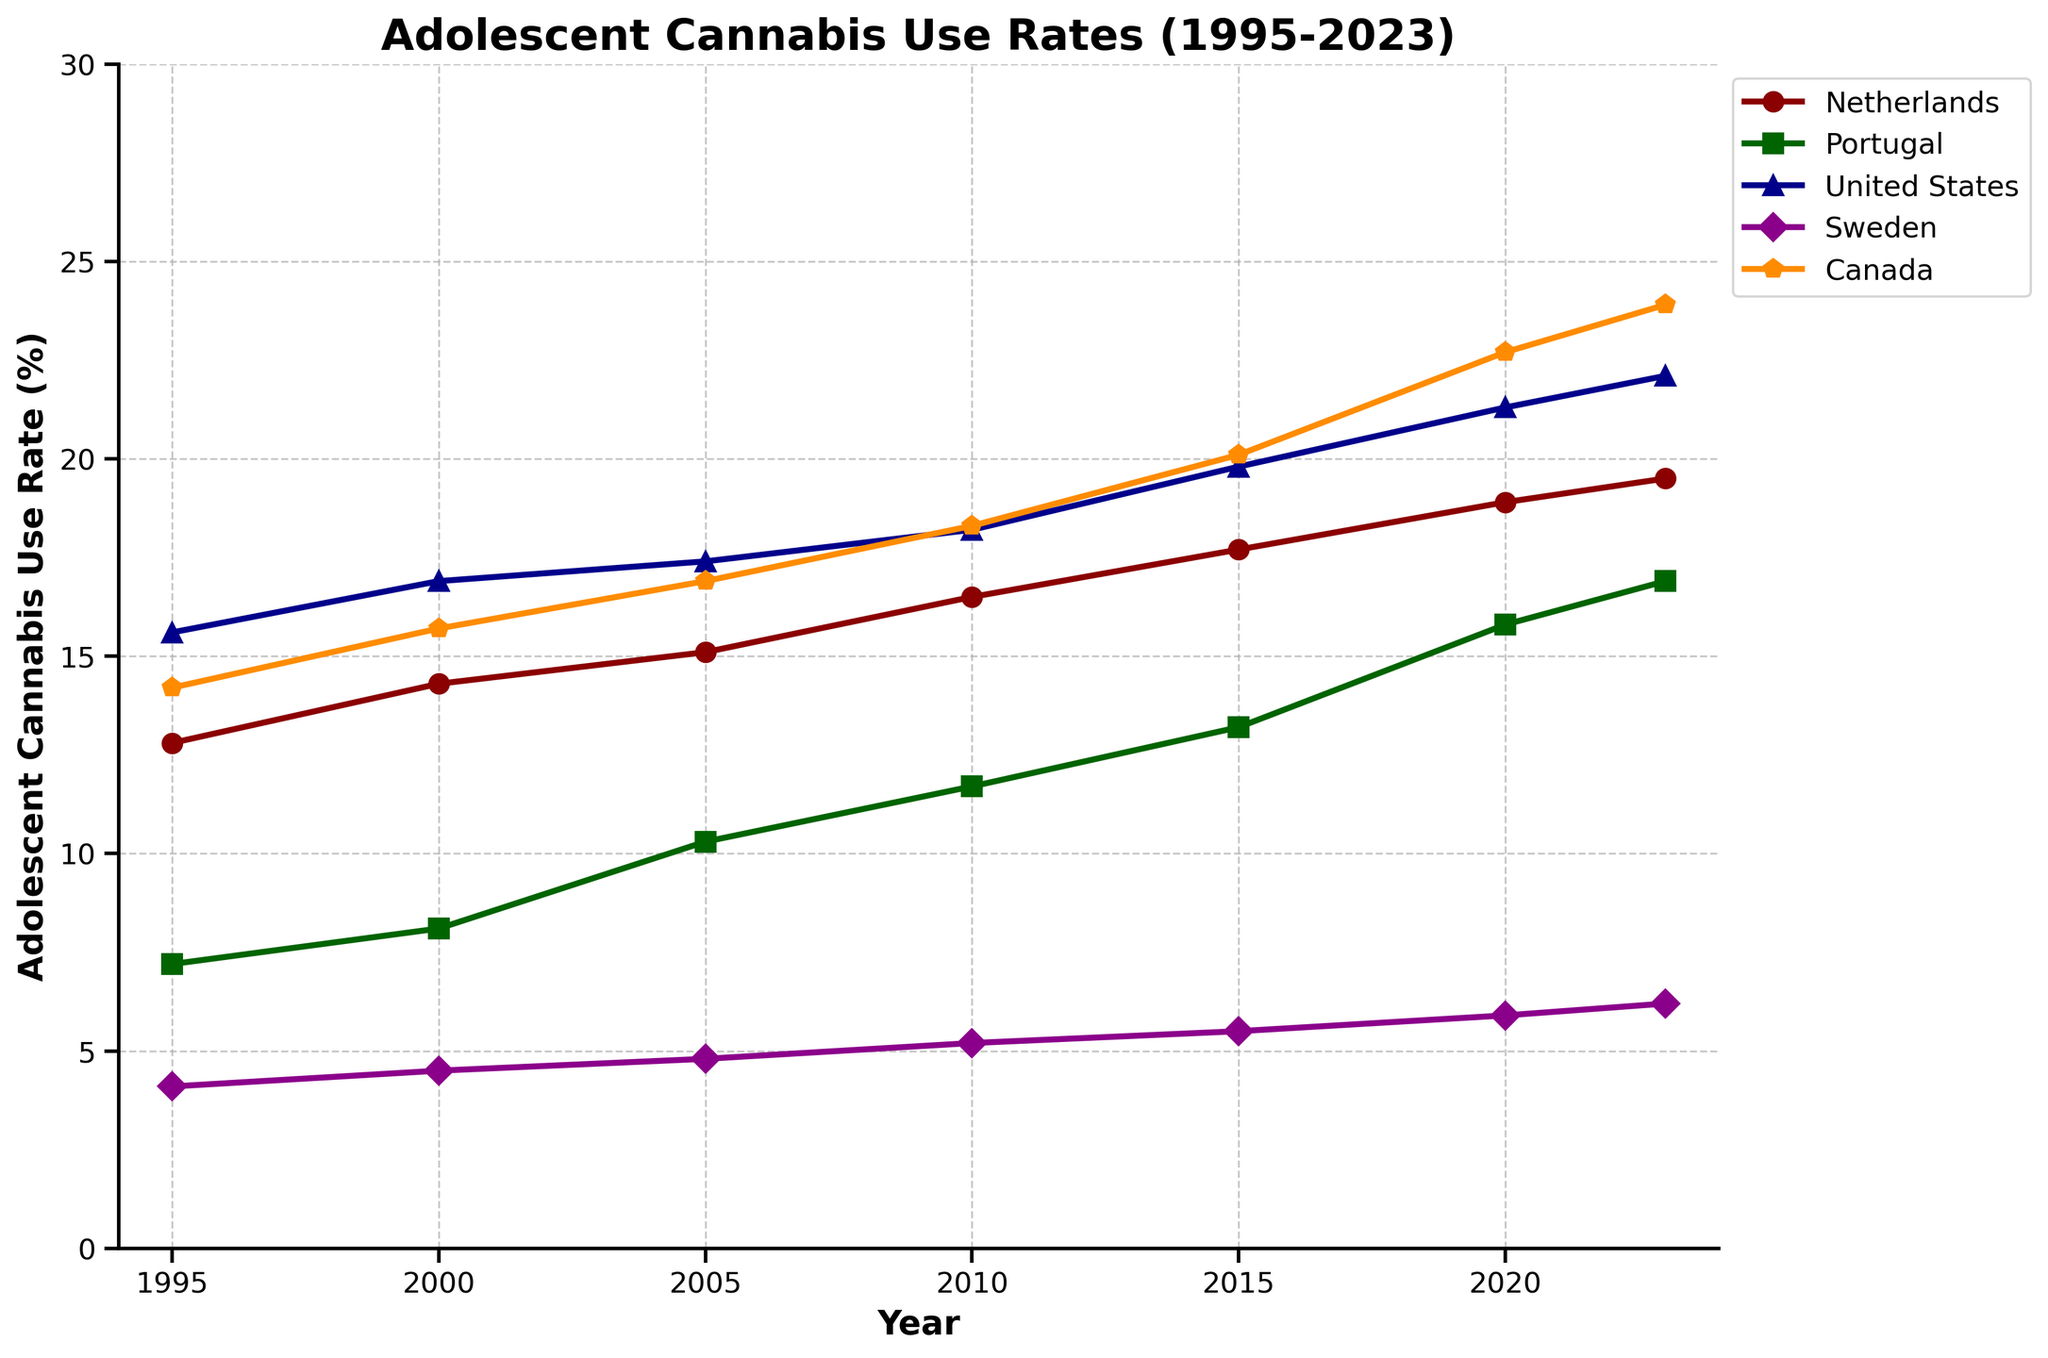What is the country with the highest adolescent cannabis use rate in 2023? To answer this, refer to the end points on the lines representing each country for the year 2023.
Answer: Canada How does the adolescent cannabis use rate in the Netherlands change from 2000 to 2023? Look at the values for the Netherlands in 2000 and 2023 and calculate the difference: 19.5% (2023) - 14.3% (2000).
Answer: It increases by 5.2% Which country shows the smallest increase in adolescent cannabis use rate from 1995 to 2023? Calculate the difference for each country and compare: Sweden (6.2% - 4.1% = 2.1%) is the smallest increase.
Answer: Sweden By how much did the adolescent cannabis use rate in the United States increase between 2010 and 2023? Find the rate values for 2010 and 2023 for the United States and subtract: 22.1% (2023) - 18.2% (2010).
Answer: 3.9% Which country had an adolescent cannabis use rate closest to 10% in 2005? Find the rate values for each country in the year 2005 and see which is closest to 10%.
Answer: Portugal (10.3%) Order the countries by their adolescent cannabis use rate in 1995 from highest to lowest. Look at the values for each country in 1995 and order them accordingly: United States (15.6%), Canada (14.2%), Netherlands (12.8%), Portugal (7.2%), Sweden (4.1%).
Answer: United States, Canada, Netherlands, Portugal, Sweden What trend do you observe for adolescent cannabis use rates in Portugal from 1995 to 2023? Analyze the slope of the line representing Portugal from 1995 to 2023; it shows a consistently increasing trend.
Answer: Consistently increasing Which country had the largest rate of increase in adolescent cannabis use between 2015 and 2020? Calculate the difference for each country between 2015 and 2020 and compare: Canada (22.7% - 20.1% = 2.6%) has the largest increase.
Answer: Canada Of the countries shown, which one has the least changing adolescent cannabis use rate over the entire period? Compare the overall changes (slope of lines) for all countries; Sweden shows the least change.
Answer: Sweden Based on the data, is there a country where the adolescent cannabis use rate decreased from 1995 to 2023? Check the lines for each country from 1995 to 2023; all lines show an increasing trend.
Answer: No 